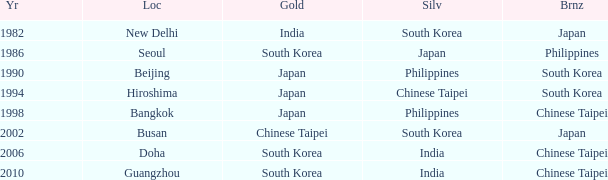How many years has Japan won silver? 1986.0. 